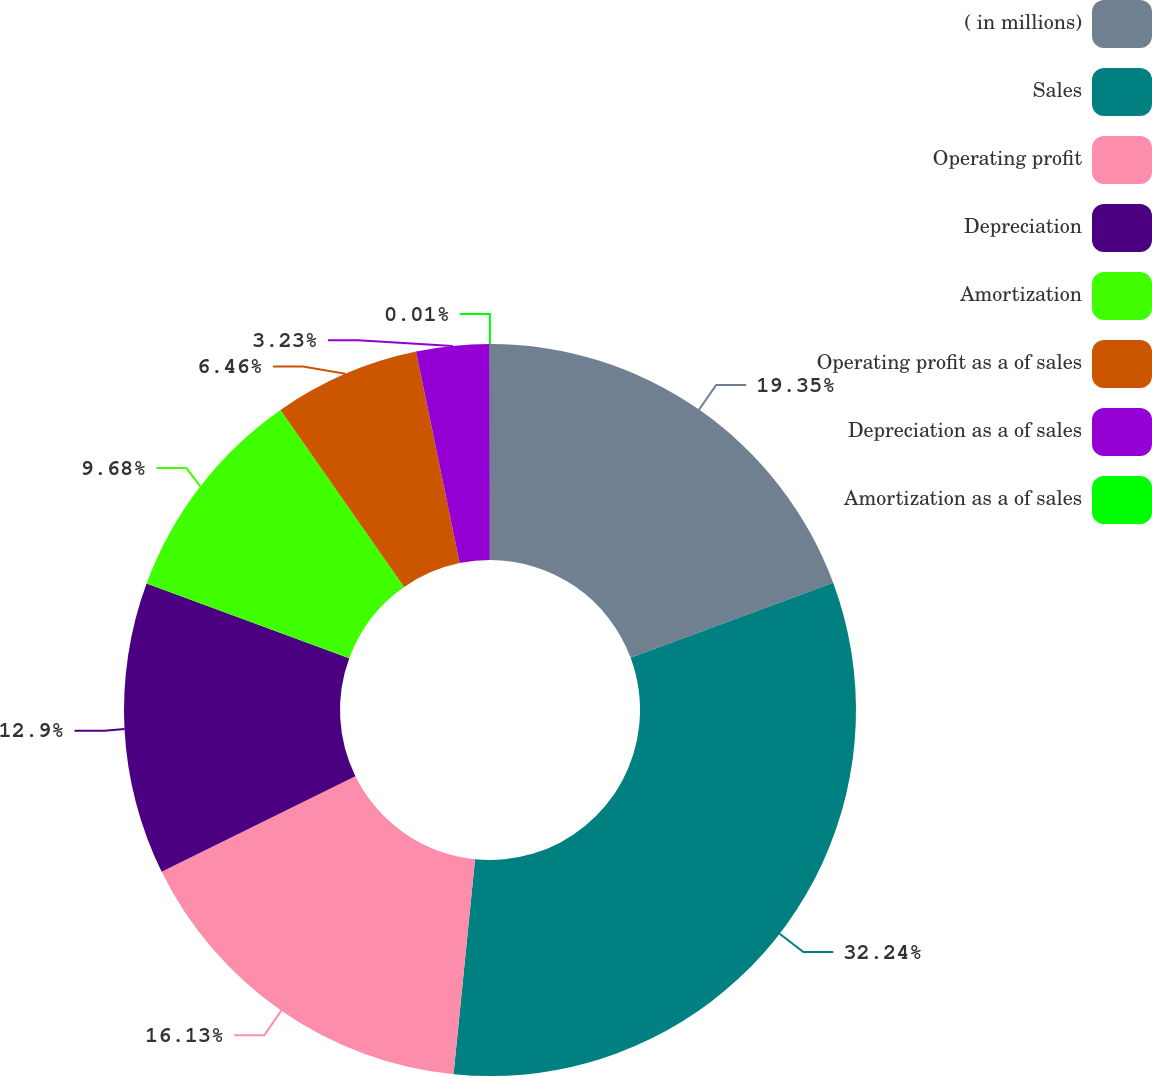Convert chart. <chart><loc_0><loc_0><loc_500><loc_500><pie_chart><fcel>( in millions)<fcel>Sales<fcel>Operating profit<fcel>Depreciation<fcel>Amortization<fcel>Operating profit as a of sales<fcel>Depreciation as a of sales<fcel>Amortization as a of sales<nl><fcel>19.35%<fcel>32.24%<fcel>16.13%<fcel>12.9%<fcel>9.68%<fcel>6.46%<fcel>3.23%<fcel>0.01%<nl></chart> 